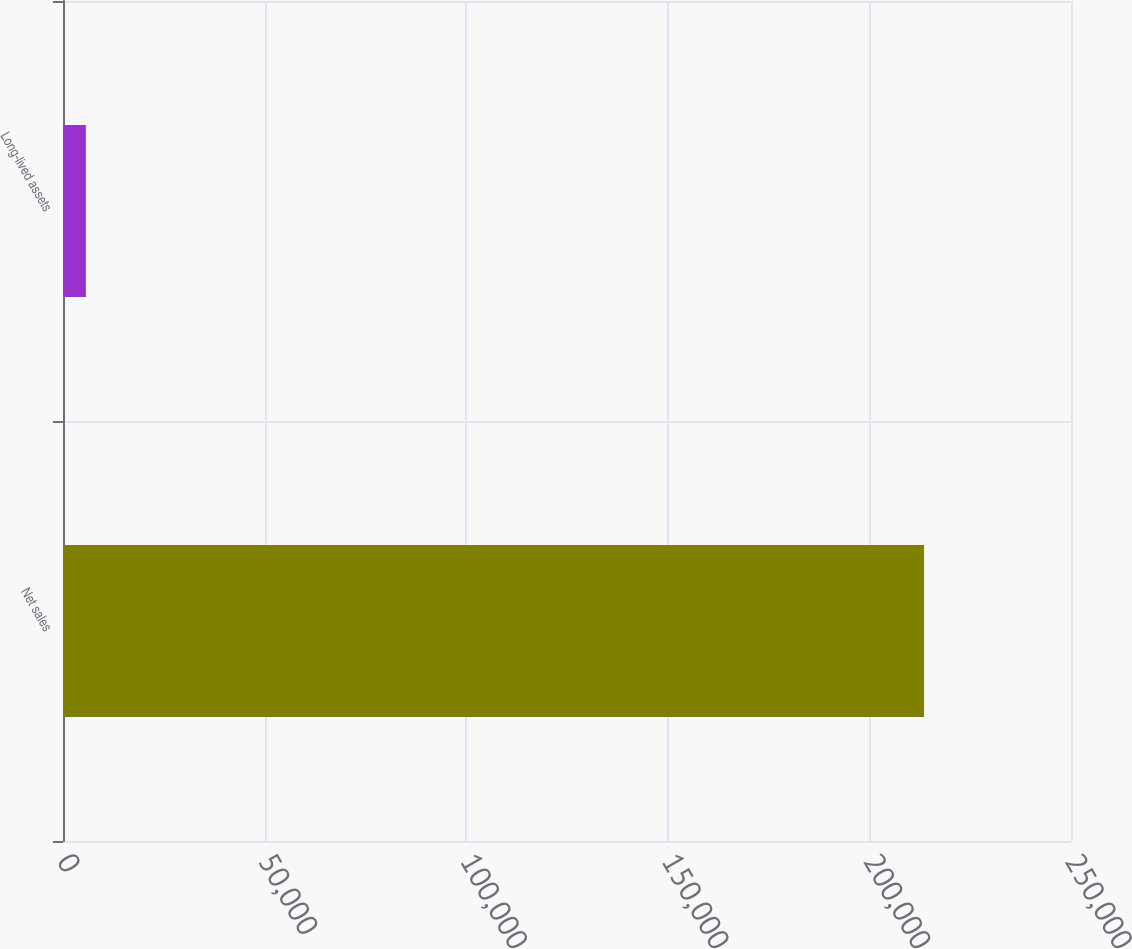Convert chart. <chart><loc_0><loc_0><loc_500><loc_500><bar_chart><fcel>Net sales<fcel>Long-lived assets<nl><fcel>213559<fcel>5669<nl></chart> 